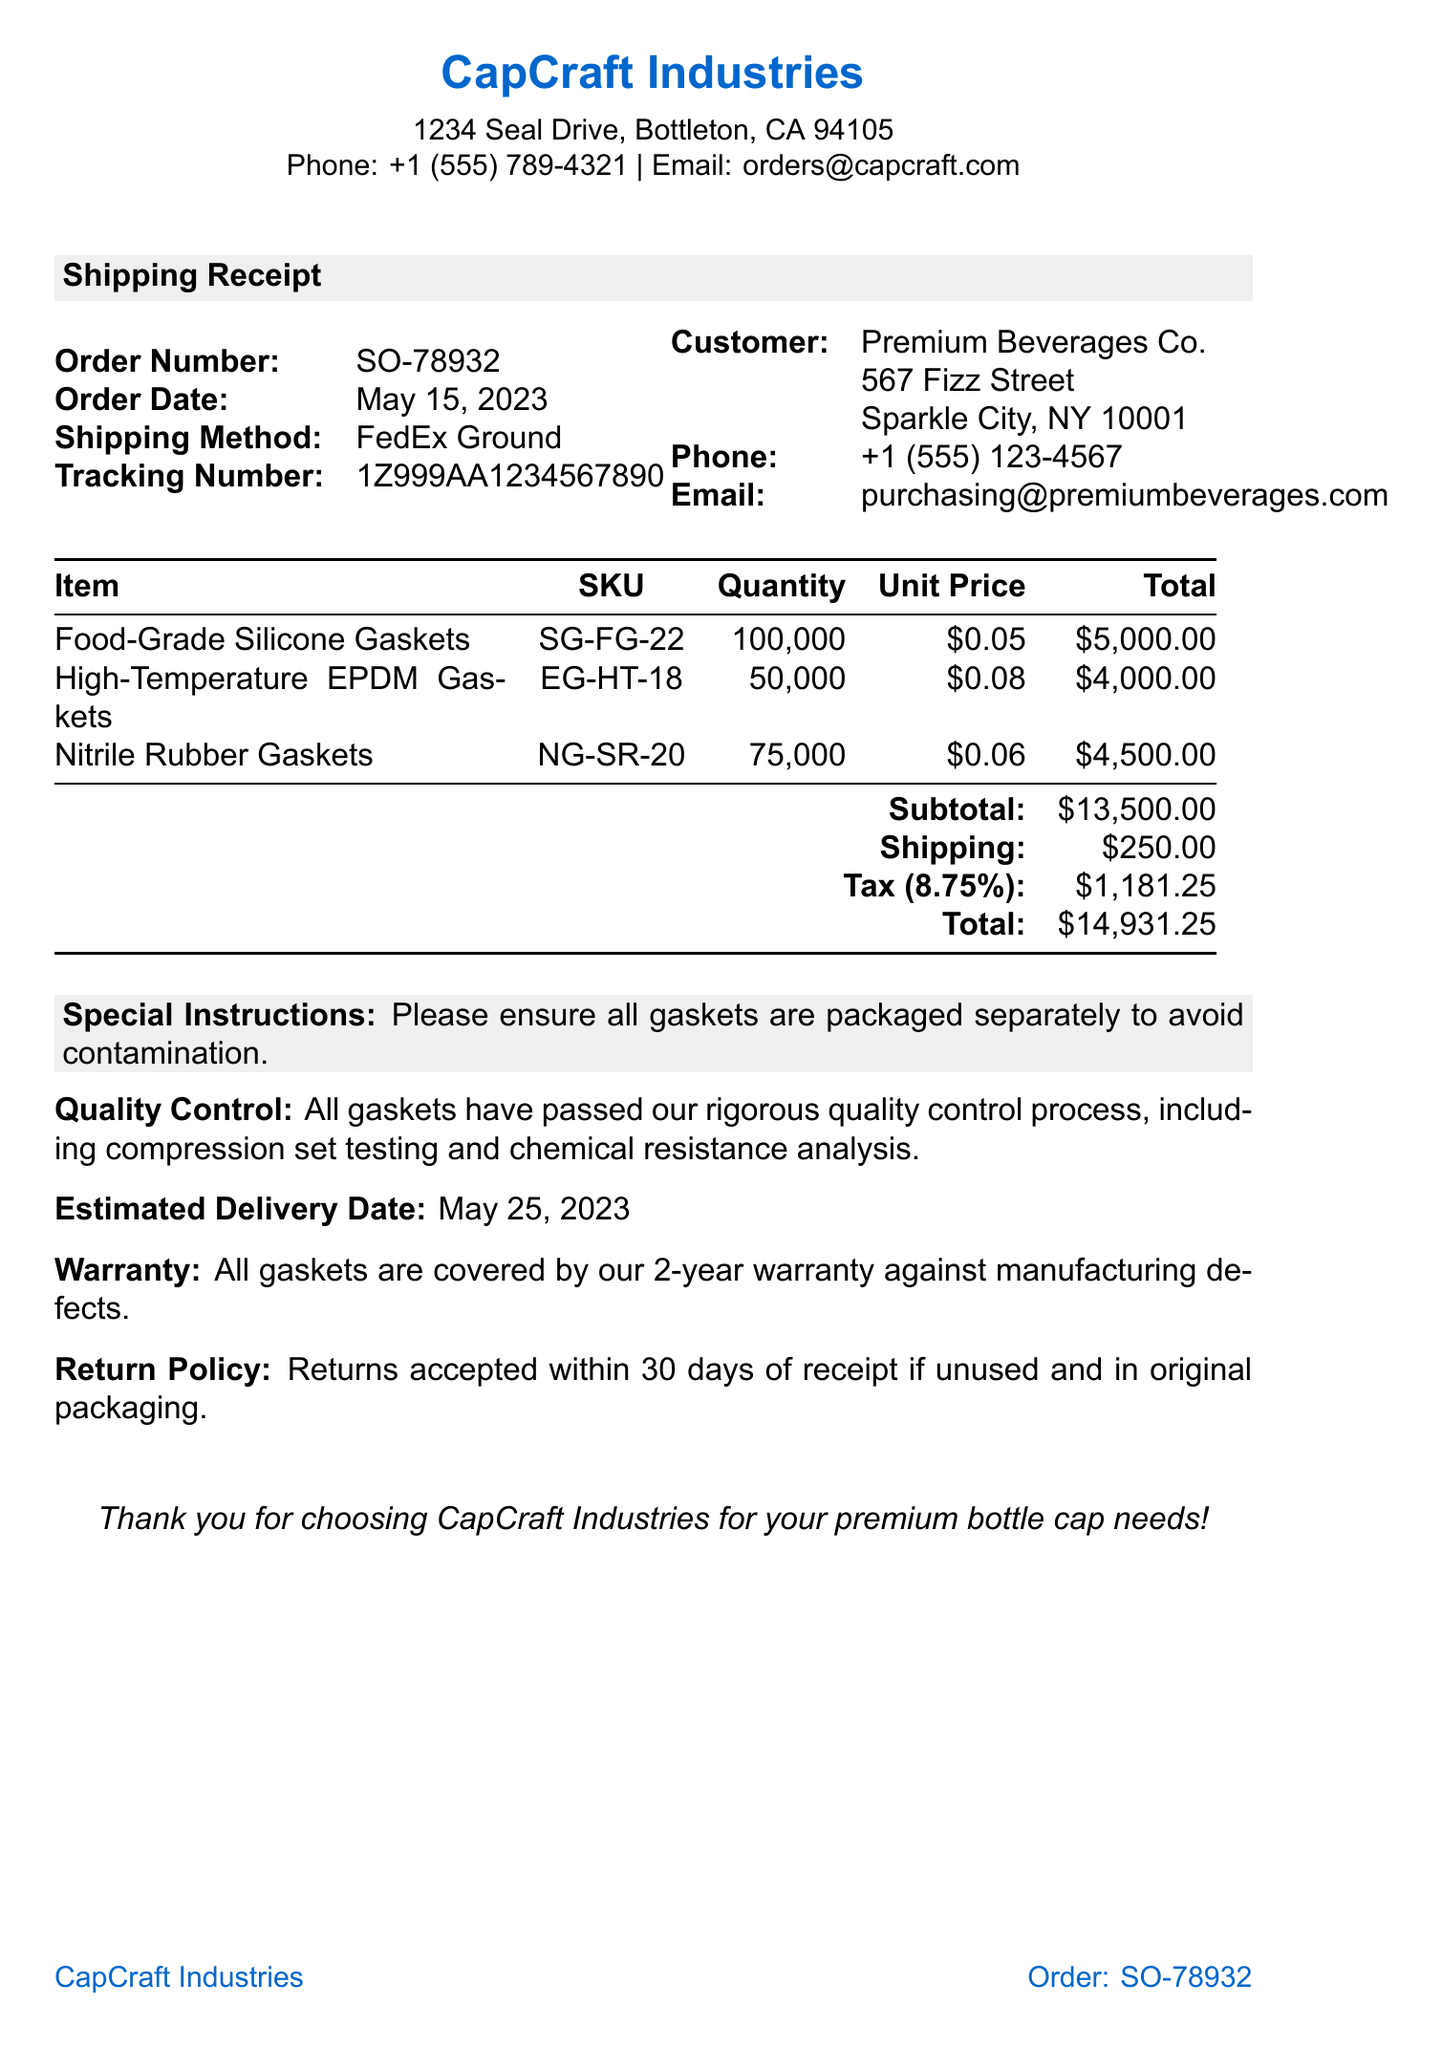What is the order number? The order number is explicitly stated in the document as SO-78932.
Answer: SO-78932 What is the total amount due? The total amount due can be found at the bottom of the receipt, which is $14,931.25.
Answer: $14,931.25 What is the shipping method used? The shipping method selected for this order is written as FedEx Ground.
Answer: FedEx Ground How many High-Temperature EPDM Gaskets were ordered? The quantity of High-Temperature EPDM Gaskets listed in the document is 50,000.
Answer: 50,000 What is the warranty period for the gaskets? The warranty provided for the gaskets is mentioned as 2 years against manufacturing defects.
Answer: 2-year What is the tax rate applied to the order? The tax rate mentioned in the document is 8.75%.
Answer: 8.75% What are the special instructions for packaging? The special instructions noted in the document request to ensure all gaskets are packaged separately to avoid contamination.
Answer: Please ensure all gaskets are packaged separately to avoid contamination What should be done to return items? The return policy specifies that returns are accepted within 30 days of receipt if unused and in original packaging.
Answer: Returns accepted within 30 days of receipt if unused and in original packaging What quality control measures were mentioned? The document states that all gaskets have passed a rigorous quality control process, which includes compression set testing and chemical resistance analysis.
Answer: All gaskets have passed our rigorous quality control process, including compression set testing and chemical resistance analysis 